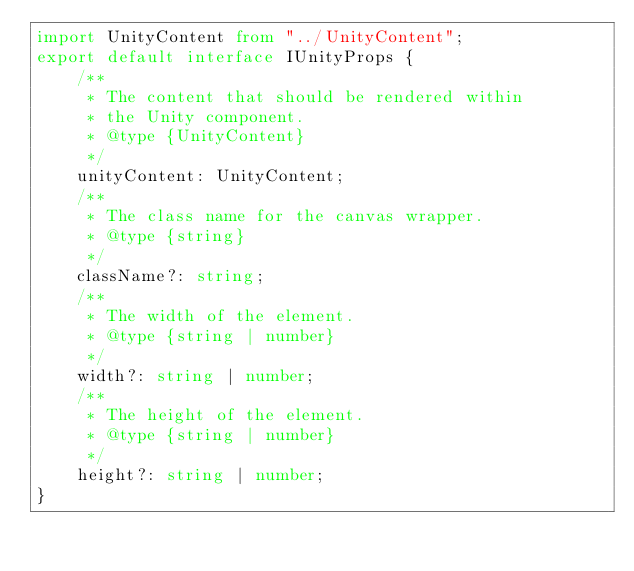<code> <loc_0><loc_0><loc_500><loc_500><_TypeScript_>import UnityContent from "../UnityContent";
export default interface IUnityProps {
    /**
     * The content that should be rendered within
     * the Unity component.
     * @type {UnityContent}
     */
    unityContent: UnityContent;
    /**
     * The class name for the canvas wrapper.
     * @type {string}
     */
    className?: string;
    /**
     * The width of the element.
     * @type {string | number}
     */
    width?: string | number;
    /**
     * The height of the element.
     * @type {string | number}
     */
    height?: string | number;
}</code> 